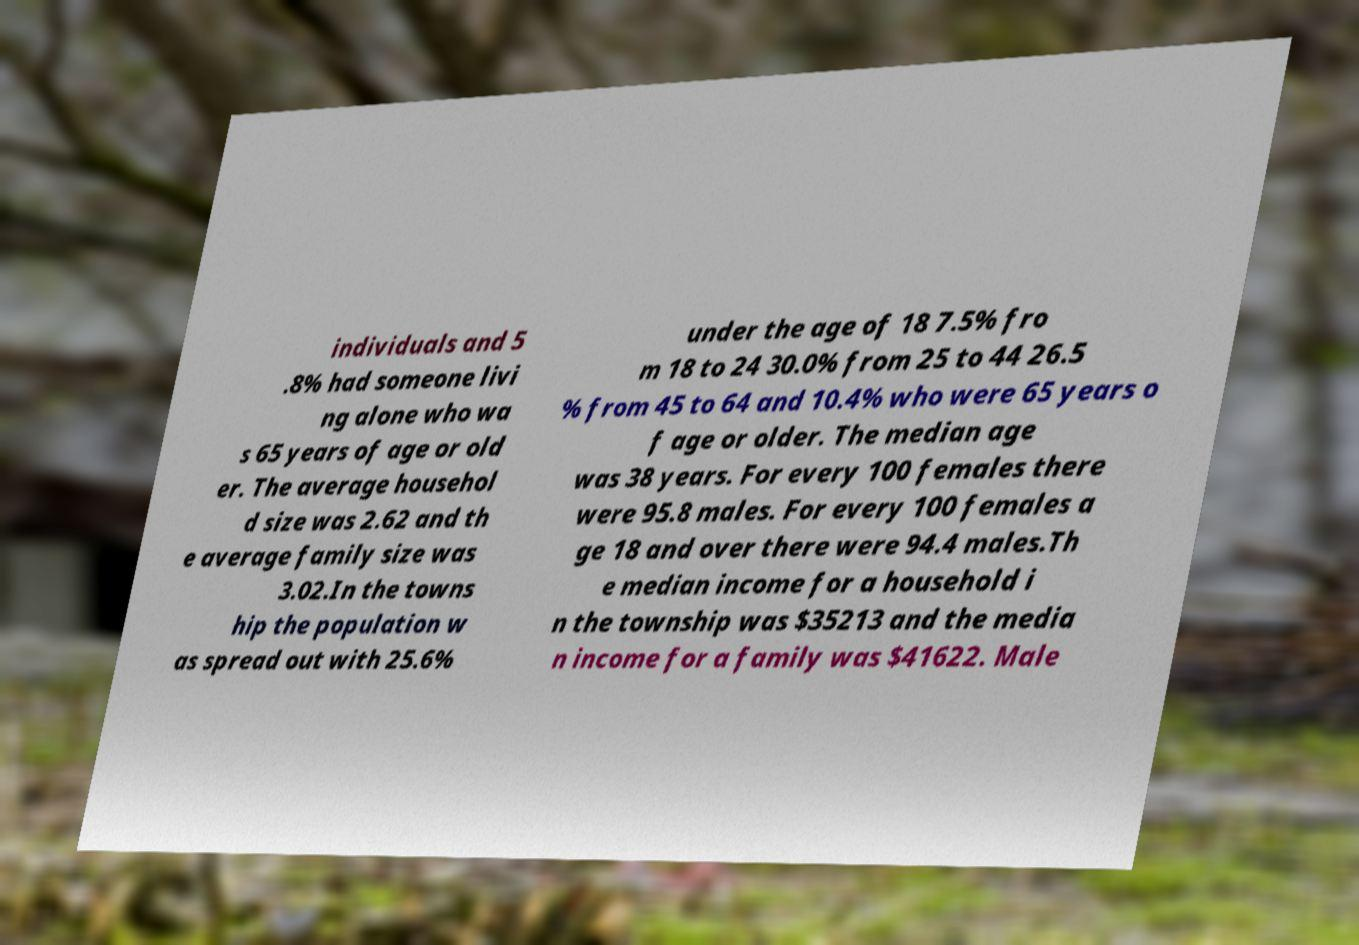Please read and relay the text visible in this image. What does it say? individuals and 5 .8% had someone livi ng alone who wa s 65 years of age or old er. The average househol d size was 2.62 and th e average family size was 3.02.In the towns hip the population w as spread out with 25.6% under the age of 18 7.5% fro m 18 to 24 30.0% from 25 to 44 26.5 % from 45 to 64 and 10.4% who were 65 years o f age or older. The median age was 38 years. For every 100 females there were 95.8 males. For every 100 females a ge 18 and over there were 94.4 males.Th e median income for a household i n the township was $35213 and the media n income for a family was $41622. Male 